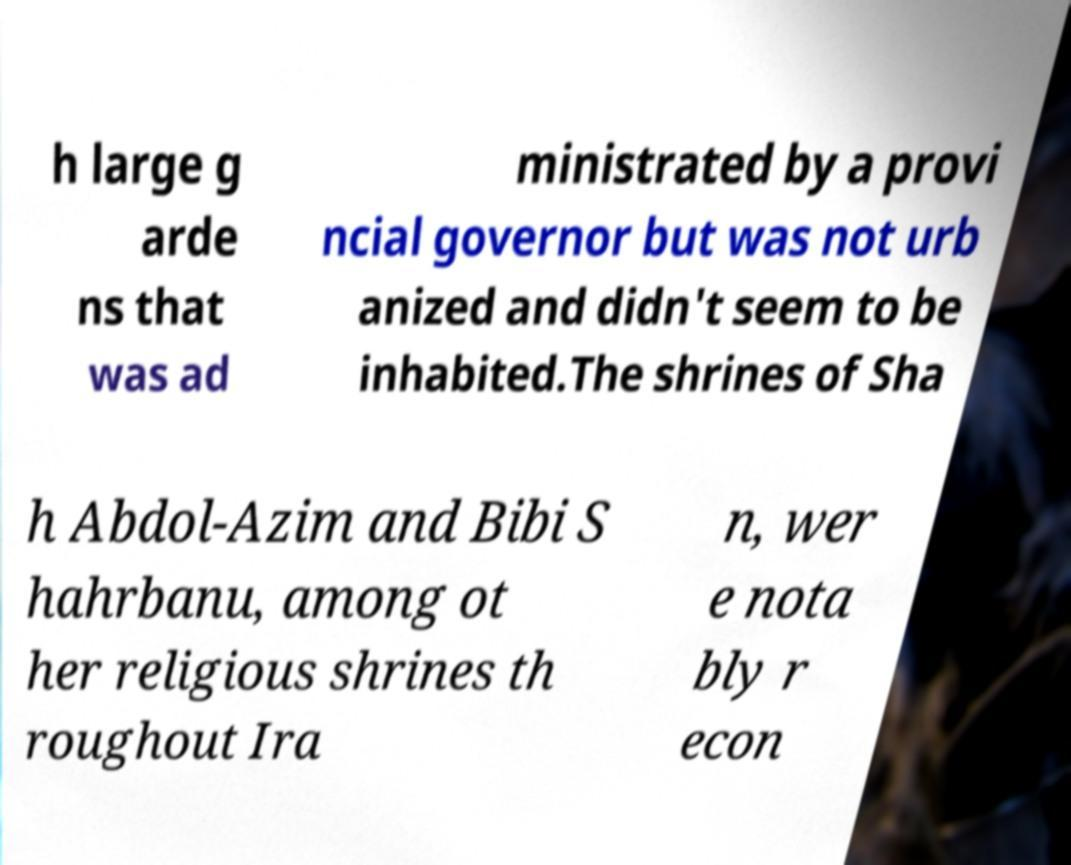Please read and relay the text visible in this image. What does it say? h large g arde ns that was ad ministrated by a provi ncial governor but was not urb anized and didn't seem to be inhabited.The shrines of Sha h Abdol-Azim and Bibi S hahrbanu, among ot her religious shrines th roughout Ira n, wer e nota bly r econ 